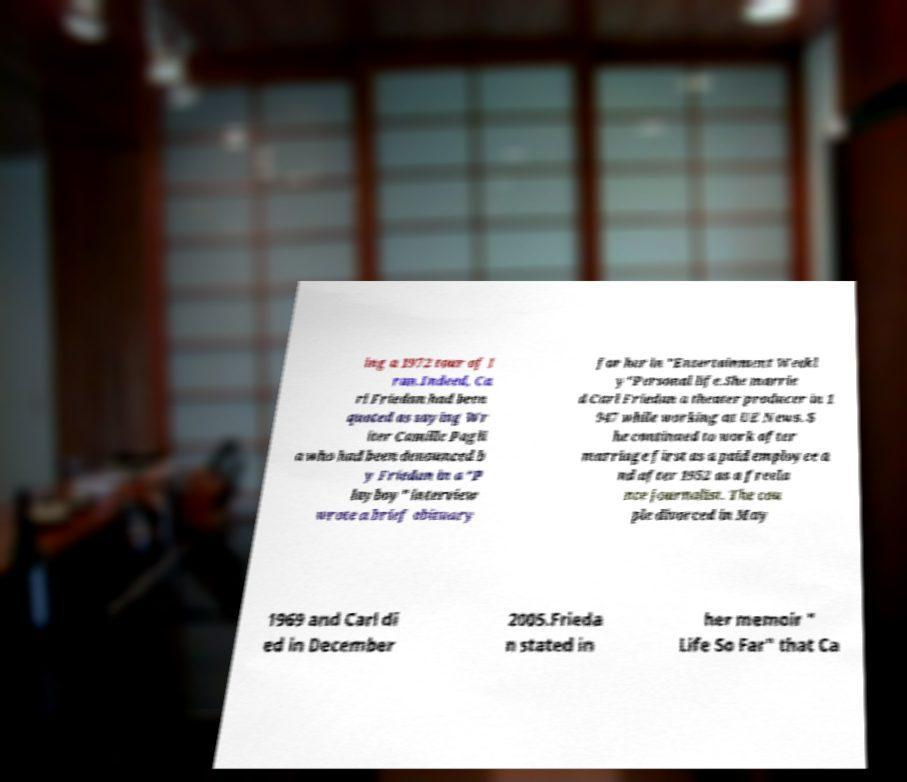What messages or text are displayed in this image? I need them in a readable, typed format. ing a 1972 tour of I ran.Indeed, Ca rl Friedan had been quoted as saying Wr iter Camille Pagli a who had been denounced b y Friedan in a "P layboy" interview wrote a brief obituary for her in "Entertainment Weekl y"Personal life.She marrie d Carl Friedan a theater producer in 1 947 while working at UE News. S he continued to work after marriage first as a paid employee a nd after 1952 as a freela nce journalist. The cou ple divorced in May 1969 and Carl di ed in December 2005.Frieda n stated in her memoir " Life So Far" that Ca 